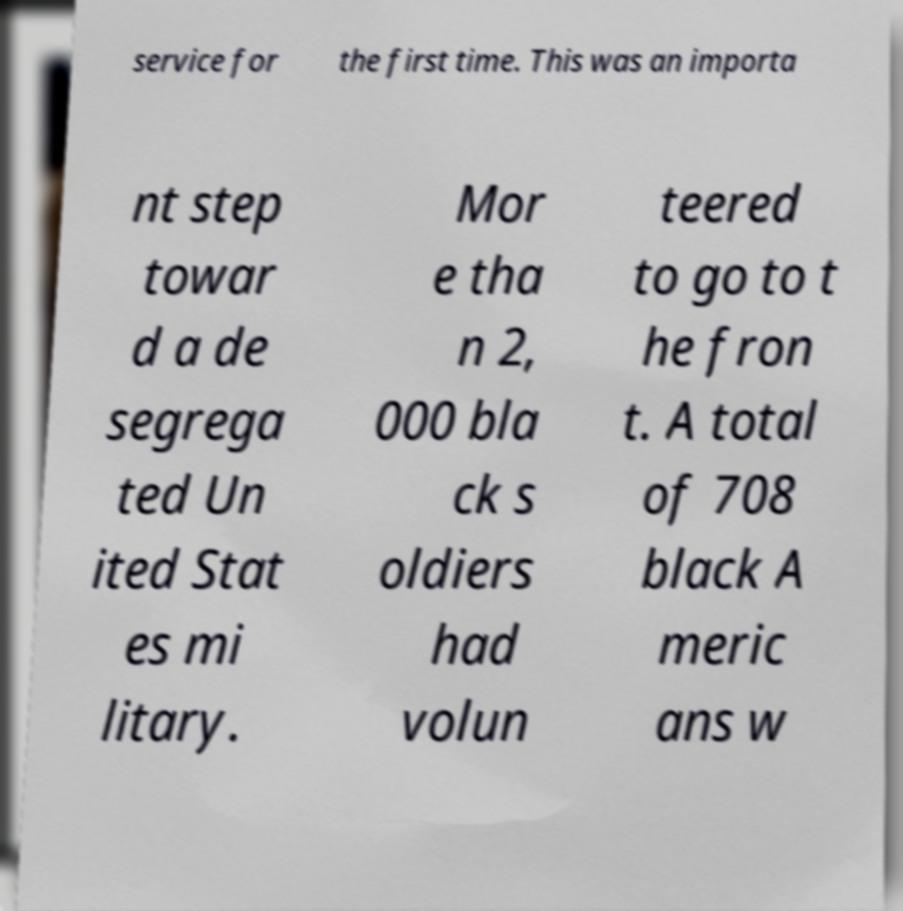Can you read and provide the text displayed in the image?This photo seems to have some interesting text. Can you extract and type it out for me? service for the first time. This was an importa nt step towar d a de segrega ted Un ited Stat es mi litary. Mor e tha n 2, 000 bla ck s oldiers had volun teered to go to t he fron t. A total of 708 black A meric ans w 